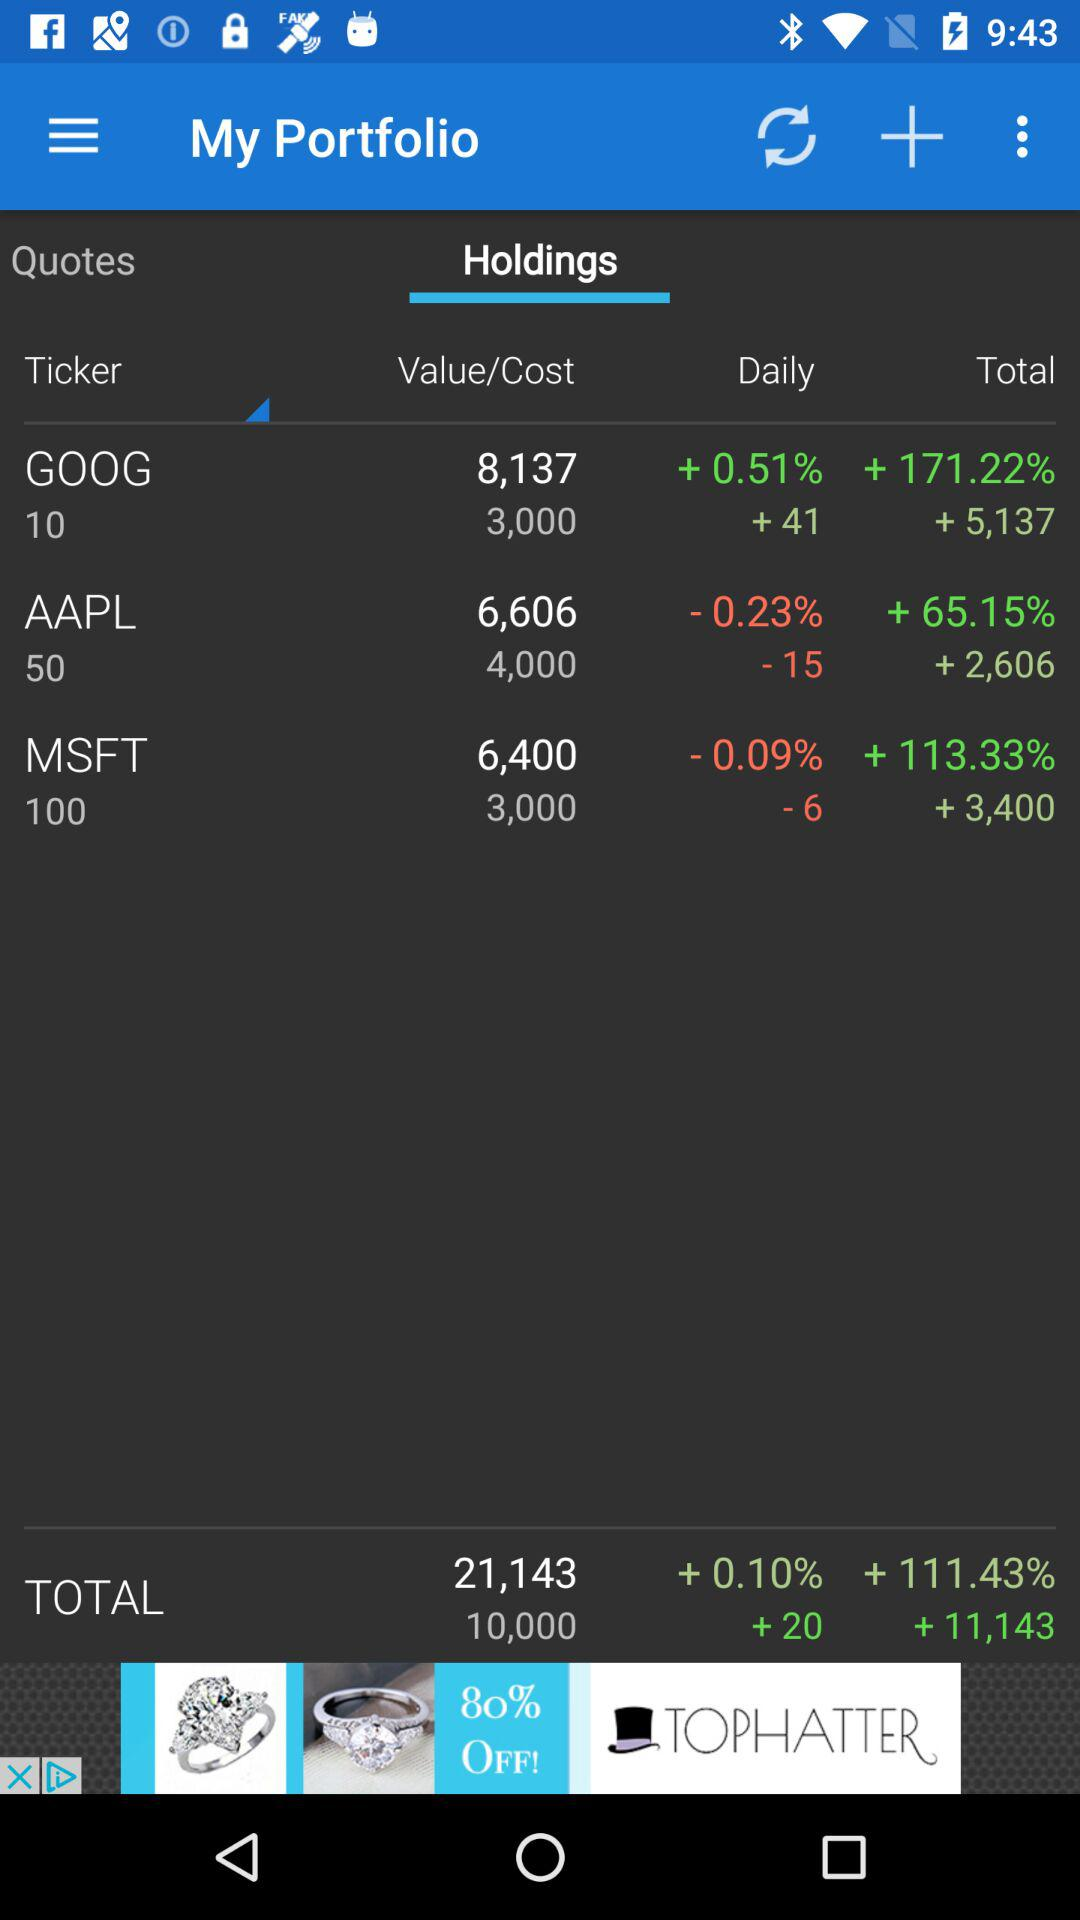Which tab is selected? The selected tab is "Holdings". 